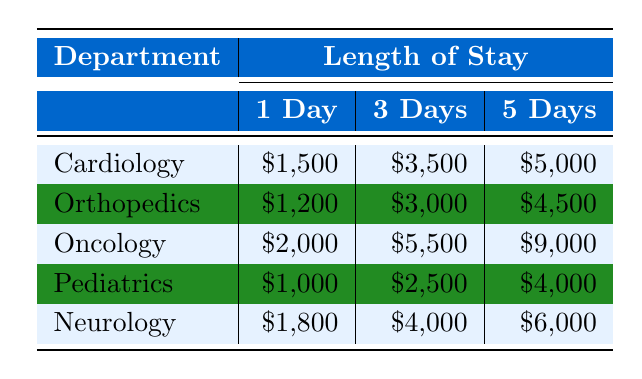What is the average treatment cost for 1-day stays across all departments? The average treatment cost for 1-day stays can be calculated by summing the costs for each department that has a 1-day stay and dividing by the number of departments. The costs are: \$1,500 (Cardiology), \$1,200 (Orthopedics), \$2,000 (Oncology), \$1,000 (Pediatrics), and \$1,800 (Neurology). The sum is \$1,500 + \$1,200 + \$2,000 + \$1,000 + \$1,800 = \$7,500. There are 5 departments, so the average is \$7,500 / 5 = \$1,500.
Answer: 1500 Which department has the highest average cost for a 3-day stay? By checking the 3-day costs listed, we find: \$3,500 (Cardiology), \$3,000 (Orthopedics), \$5,500 (Oncology), \$2,500 (Pediatrics), and \$4,000 (Neurology). The highest cost among these is \$5,500, which belongs to Oncology.
Answer: Oncology Is it true that the treatment cost for a 5-day stay is the same for Orthopedics and Pediatrics? Comparing the 5-day treatment costs, Orthopedics has \$4,500 while Pediatrics has \$4,000. Since these amounts are different, the statement is false.
Answer: No What is the difference in average treatment cost between Cardiology and Neurosurgery for 1-Day stays? Neurology is included instead of Neurosurgery, as it is not in the provided data. For Cardiology the cost is \$1,500 and for Neurology it’s \$1,800. The difference is calculated as \$1,800 - \$1,500 = \$300.
Answer: 300 How much would a 3-day stay cost in total across all departments? The total for 3-day stays is calculated by summing the individual costs: \$3,500 (Cardiology) + \$3,000 (Orthopedics) + \$5,500 (Oncology) + \$2,500 (Pediatrics) + \$4,000 (Neurology) = \$18,500.
Answer: 18500 